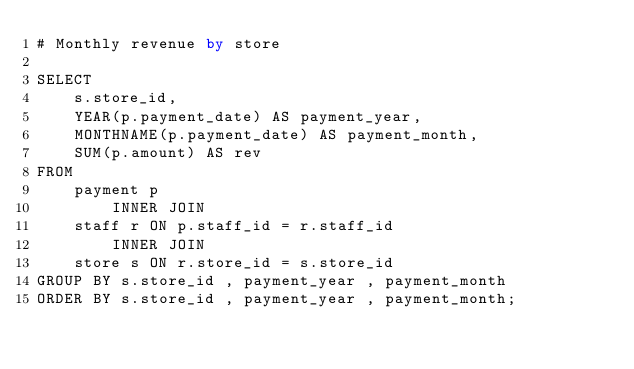<code> <loc_0><loc_0><loc_500><loc_500><_SQL_># Monthly revenue by store 

SELECT 
    s.store_id,
    YEAR(p.payment_date) AS payment_year,
    MONTHNAME(p.payment_date) AS payment_month,
    SUM(p.amount) AS rev
FROM
    payment p
        INNER JOIN
    staff r ON p.staff_id = r.staff_id
        INNER JOIN
    store s ON r.store_id = s.store_id
GROUP BY s.store_id , payment_year , payment_month
ORDER BY s.store_id , payment_year , payment_month;</code> 